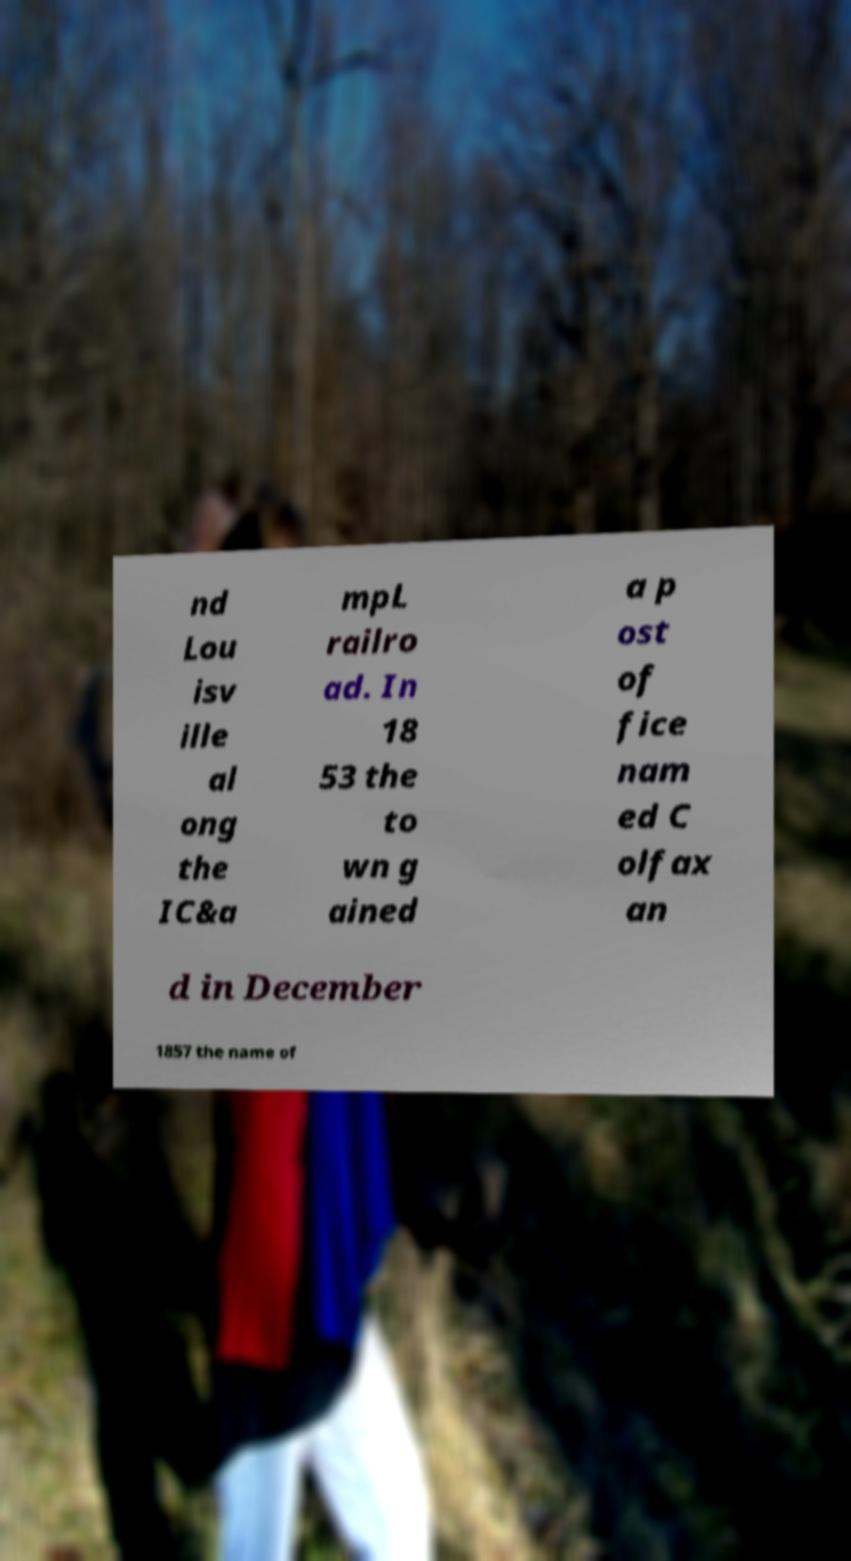Can you accurately transcribe the text from the provided image for me? nd Lou isv ille al ong the IC&a mpL railro ad. In 18 53 the to wn g ained a p ost of fice nam ed C olfax an d in December 1857 the name of 